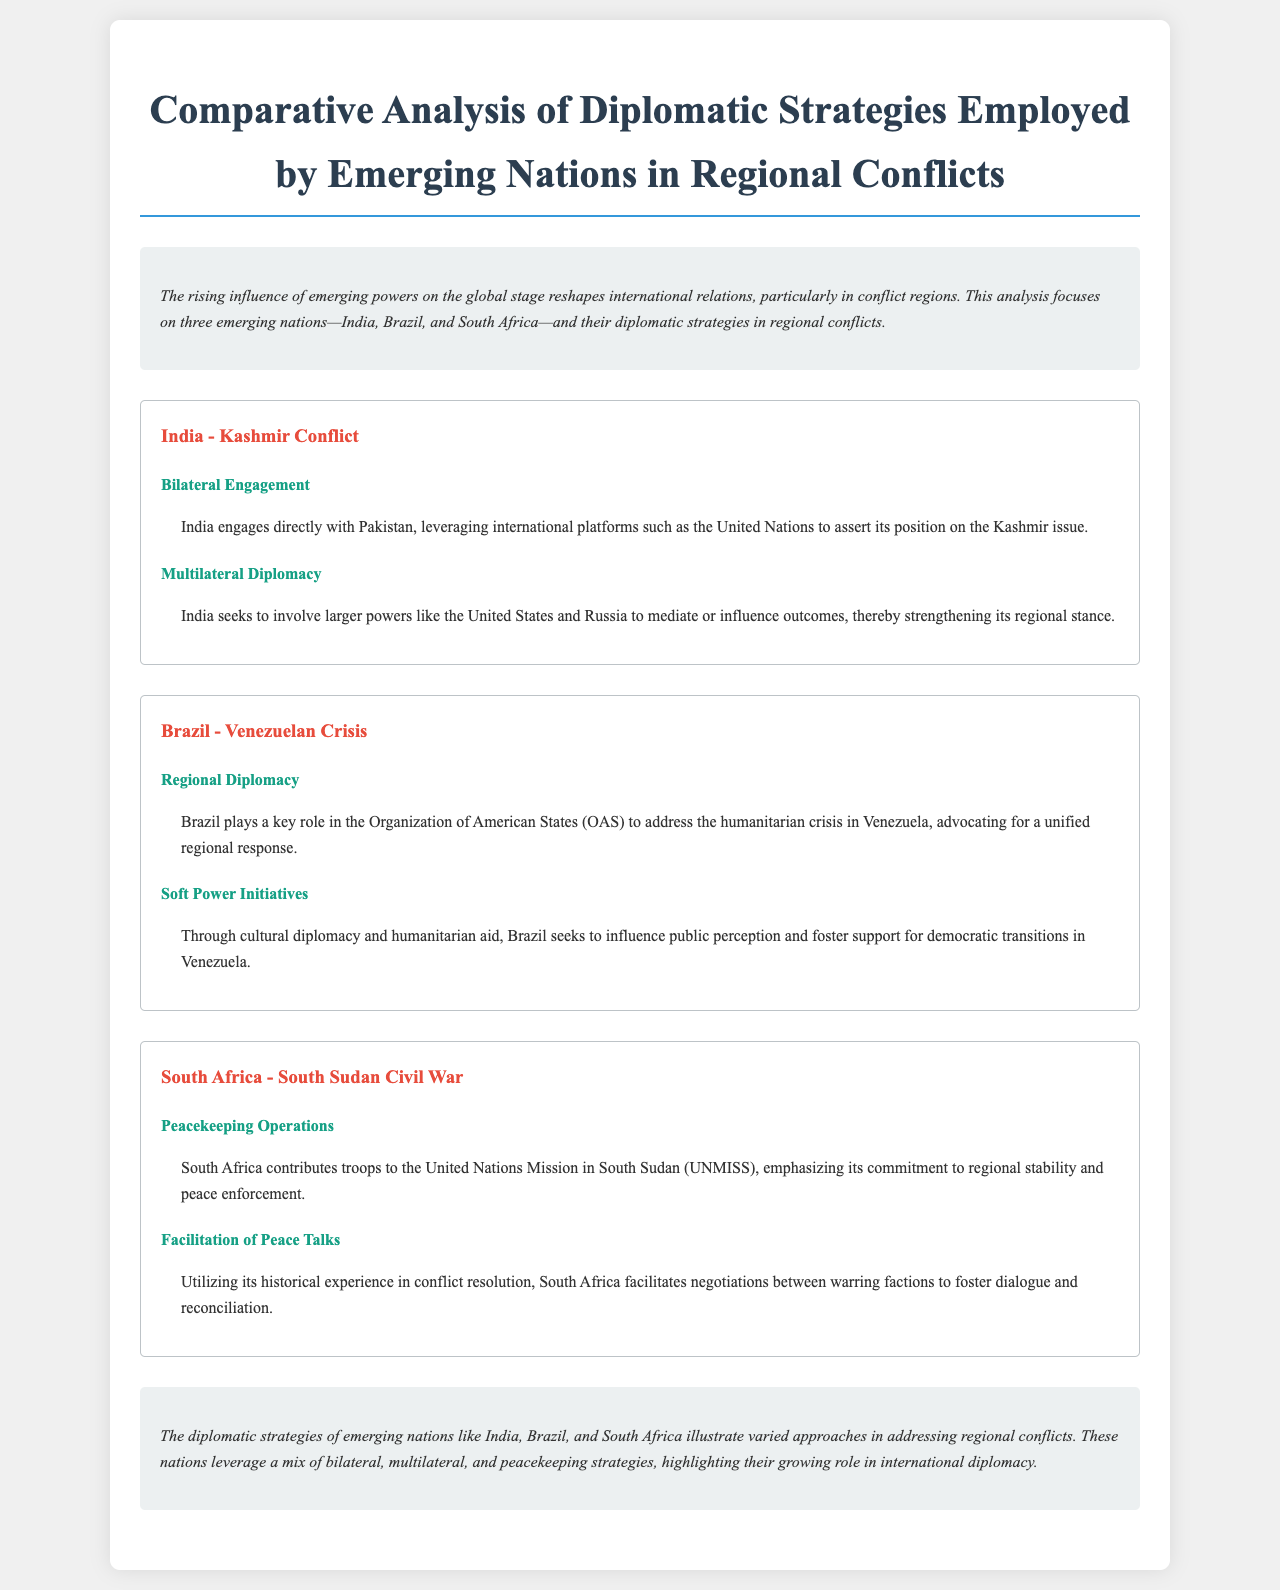What is the main focus of the analysis? The analysis focuses on the rising influence of emerging powers on the global stage, particularly in conflict regions.
Answer: emerging powers Which country is involved in the Kashmir conflict? The document states that India is directly engaged in the Kashmir conflict with Pakistan.
Answer: India What type of diplomacy does Brazil employ regarding the Venezuelan crisis? The document mentions that Brazil plays a key role in the Organization of American States (OAS) to address the crisis.
Answer: Regional Diplomacy What is South Africa's contribution to the South Sudan Civil War? The document notes that South Africa contributes troops to the United Nations Mission in South Sudan (UNMISS).
Answer: Peacekeeping Operations Which international platform does India leverage for the Kashmir issue? The document specifies that India leverages international platforms like the United Nations.
Answer: United Nations What is one way Brazil uses soft power regarding the Venezuelan crisis? The document states that Brazil uses cultural diplomacy and humanitarian aid to influence public perception.
Answer: Humanitarian aid 